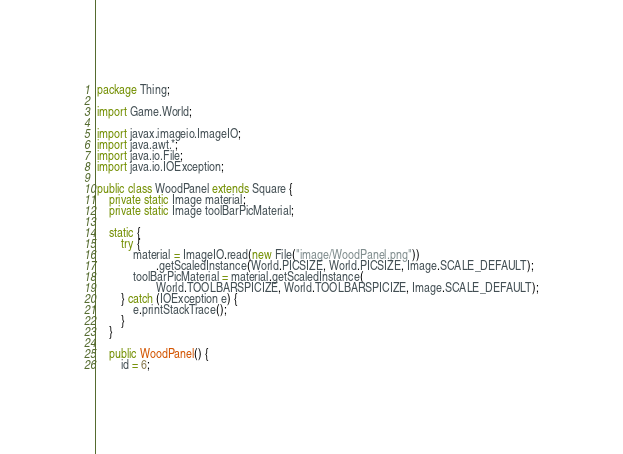<code> <loc_0><loc_0><loc_500><loc_500><_Java_>package Thing;

import Game.World;

import javax.imageio.ImageIO;
import java.awt.*;
import java.io.File;
import java.io.IOException;

public class WoodPanel extends Square {
    private static Image material;
    private static Image toolBarPicMaterial;

    static {
        try {
            material = ImageIO.read(new File("image/WoodPanel.png"))
                    .getScaledInstance(World.PICSIZE, World.PICSIZE, Image.SCALE_DEFAULT);
            toolBarPicMaterial = material.getScaledInstance(
                    World.TOOLBARSPICIZE, World.TOOLBARSPICIZE, Image.SCALE_DEFAULT);
        } catch (IOException e) {
            e.printStackTrace();
        }
    }

    public WoodPanel() {
        id = 6;</code> 